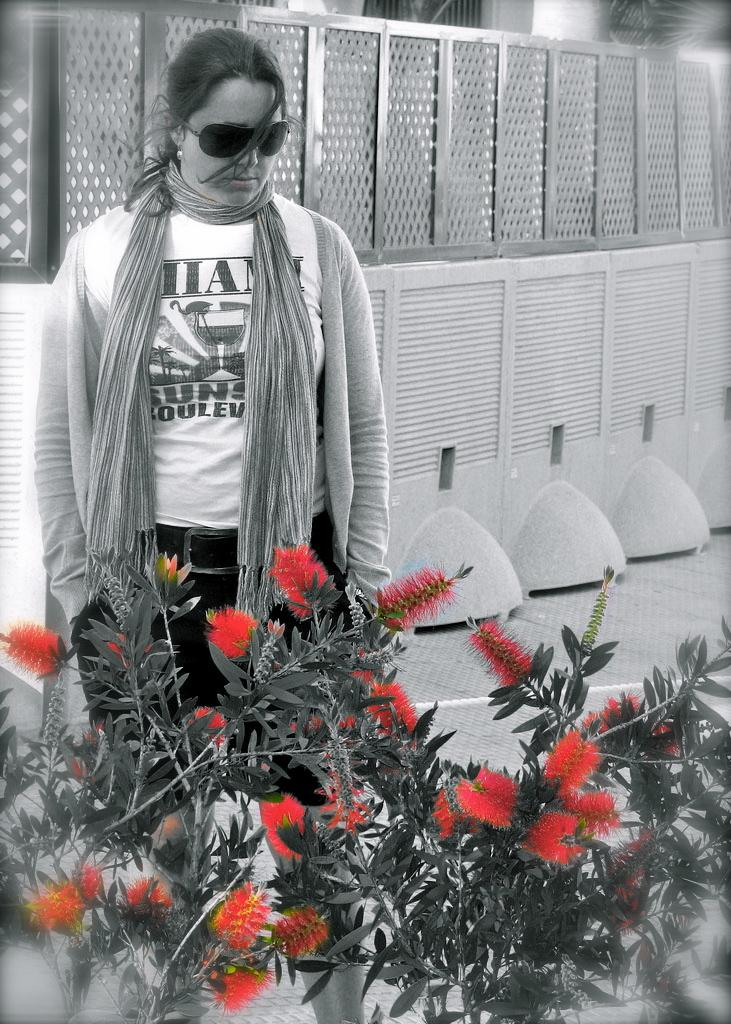What is the color scheme of the image? The image is black and white. What type of plants can be seen in the image? There are plants with red flowers in the image. Can you describe the woman in the image? A woman is standing in the image. What can be seen in the background of the image? There are plants and a wall in the background of the image, along with some objects. What type of songs can be heard playing from the desk in the image? There is no desk present in the image, and therefore no songs can be heard playing from it. 